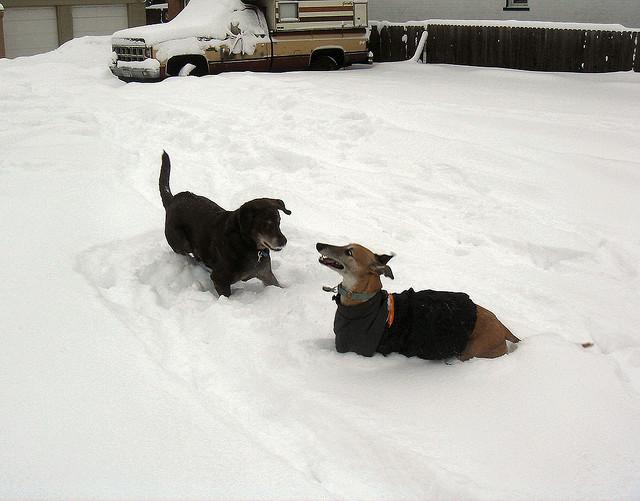How many dogs are playing in the snow?
Quick response, please. 2. Are both dogs wearing coats?
Concise answer only. No. What are the dogs doing?
Quick response, please. Playing. 